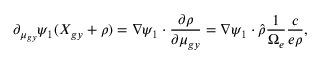Convert formula to latex. <formula><loc_0><loc_0><loc_500><loc_500>\partial _ { \mu _ { g y } } \psi _ { 1 } ( X _ { g y } + \rho ) = \nabla \psi _ { 1 } \cdot \frac { \partial \rho } { \partial \mu _ { g y } } = \nabla \psi _ { 1 } \cdot \hat { \rho } \frac { 1 } { \Omega _ { e } } \frac { c } { e \rho } ,</formula> 